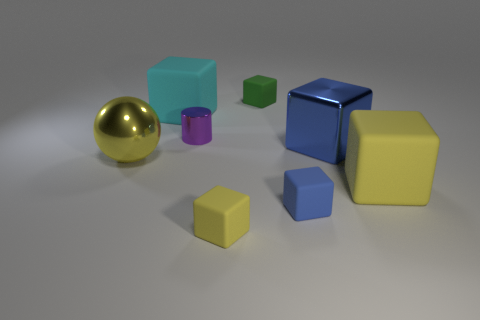Subtract all yellow blocks. How many blocks are left? 4 Subtract all cyan blocks. How many blocks are left? 5 Subtract 1 blocks. How many blocks are left? 5 Subtract all cyan cubes. Subtract all brown cylinders. How many cubes are left? 5 Add 1 big red matte cylinders. How many objects exist? 9 Subtract all cylinders. How many objects are left? 7 Add 6 big matte cubes. How many big matte cubes are left? 8 Add 1 tiny yellow cubes. How many tiny yellow cubes exist? 2 Subtract 0 blue balls. How many objects are left? 8 Subtract all big blue cubes. Subtract all yellow rubber blocks. How many objects are left? 5 